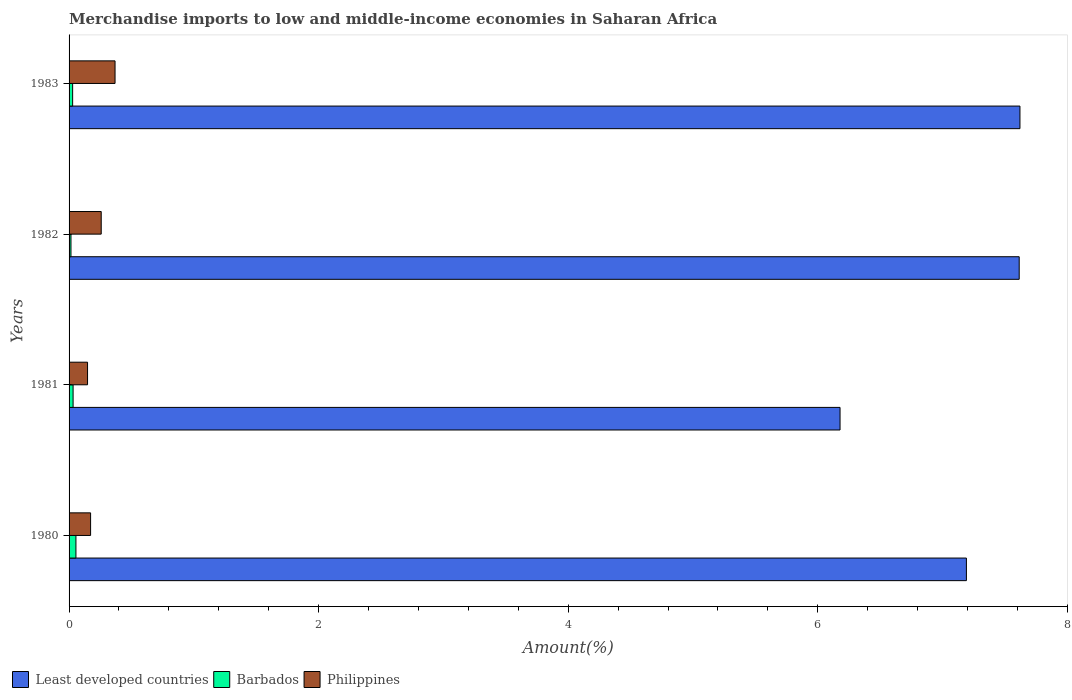How many different coloured bars are there?
Your answer should be very brief. 3. How many groups of bars are there?
Keep it short and to the point. 4. How many bars are there on the 1st tick from the bottom?
Your response must be concise. 3. What is the percentage of amount earned from merchandise imports in Philippines in 1980?
Ensure brevity in your answer.  0.17. Across all years, what is the maximum percentage of amount earned from merchandise imports in Barbados?
Offer a very short reply. 0.05. Across all years, what is the minimum percentage of amount earned from merchandise imports in Least developed countries?
Offer a terse response. 6.18. In which year was the percentage of amount earned from merchandise imports in Philippines minimum?
Offer a very short reply. 1981. What is the total percentage of amount earned from merchandise imports in Barbados in the graph?
Offer a terse response. 0.13. What is the difference between the percentage of amount earned from merchandise imports in Least developed countries in 1980 and that in 1983?
Provide a short and direct response. -0.43. What is the difference between the percentage of amount earned from merchandise imports in Barbados in 1981 and the percentage of amount earned from merchandise imports in Least developed countries in 1983?
Keep it short and to the point. -7.59. What is the average percentage of amount earned from merchandise imports in Philippines per year?
Provide a succinct answer. 0.24. In the year 1981, what is the difference between the percentage of amount earned from merchandise imports in Philippines and percentage of amount earned from merchandise imports in Least developed countries?
Your answer should be compact. -6.03. What is the ratio of the percentage of amount earned from merchandise imports in Least developed countries in 1981 to that in 1983?
Your response must be concise. 0.81. Is the percentage of amount earned from merchandise imports in Philippines in 1980 less than that in 1981?
Make the answer very short. No. What is the difference between the highest and the second highest percentage of amount earned from merchandise imports in Barbados?
Your response must be concise. 0.02. What is the difference between the highest and the lowest percentage of amount earned from merchandise imports in Least developed countries?
Your response must be concise. 1.44. What does the 2nd bar from the top in 1980 represents?
Provide a succinct answer. Barbados. What does the 2nd bar from the bottom in 1982 represents?
Make the answer very short. Barbados. Is it the case that in every year, the sum of the percentage of amount earned from merchandise imports in Philippines and percentage of amount earned from merchandise imports in Barbados is greater than the percentage of amount earned from merchandise imports in Least developed countries?
Offer a very short reply. No. How many bars are there?
Give a very brief answer. 12. Are all the bars in the graph horizontal?
Your answer should be very brief. Yes. How many years are there in the graph?
Your answer should be very brief. 4. Are the values on the major ticks of X-axis written in scientific E-notation?
Make the answer very short. No. Does the graph contain any zero values?
Your answer should be compact. No. Does the graph contain grids?
Keep it short and to the point. No. Where does the legend appear in the graph?
Your answer should be very brief. Bottom left. How many legend labels are there?
Your response must be concise. 3. How are the legend labels stacked?
Keep it short and to the point. Horizontal. What is the title of the graph?
Offer a very short reply. Merchandise imports to low and middle-income economies in Saharan Africa. What is the label or title of the X-axis?
Ensure brevity in your answer.  Amount(%). What is the Amount(%) in Least developed countries in 1980?
Offer a very short reply. 7.19. What is the Amount(%) in Barbados in 1980?
Ensure brevity in your answer.  0.05. What is the Amount(%) of Philippines in 1980?
Your answer should be very brief. 0.17. What is the Amount(%) of Least developed countries in 1981?
Provide a short and direct response. 6.18. What is the Amount(%) of Barbados in 1981?
Your answer should be very brief. 0.03. What is the Amount(%) of Philippines in 1981?
Your answer should be compact. 0.15. What is the Amount(%) in Least developed countries in 1982?
Provide a short and direct response. 7.61. What is the Amount(%) in Barbados in 1982?
Your response must be concise. 0.02. What is the Amount(%) of Philippines in 1982?
Your answer should be very brief. 0.26. What is the Amount(%) in Least developed countries in 1983?
Provide a short and direct response. 7.62. What is the Amount(%) of Barbados in 1983?
Your answer should be compact. 0.03. What is the Amount(%) in Philippines in 1983?
Offer a very short reply. 0.37. Across all years, what is the maximum Amount(%) of Least developed countries?
Give a very brief answer. 7.62. Across all years, what is the maximum Amount(%) in Barbados?
Provide a succinct answer. 0.05. Across all years, what is the maximum Amount(%) in Philippines?
Offer a terse response. 0.37. Across all years, what is the minimum Amount(%) of Least developed countries?
Offer a very short reply. 6.18. Across all years, what is the minimum Amount(%) of Barbados?
Give a very brief answer. 0.02. Across all years, what is the minimum Amount(%) of Philippines?
Offer a terse response. 0.15. What is the total Amount(%) of Least developed countries in the graph?
Make the answer very short. 28.6. What is the total Amount(%) of Barbados in the graph?
Ensure brevity in your answer.  0.13. What is the total Amount(%) in Philippines in the graph?
Ensure brevity in your answer.  0.95. What is the difference between the Amount(%) in Least developed countries in 1980 and that in 1981?
Ensure brevity in your answer.  1.01. What is the difference between the Amount(%) in Barbados in 1980 and that in 1981?
Provide a short and direct response. 0.02. What is the difference between the Amount(%) of Philippines in 1980 and that in 1981?
Provide a succinct answer. 0.02. What is the difference between the Amount(%) of Least developed countries in 1980 and that in 1982?
Keep it short and to the point. -0.42. What is the difference between the Amount(%) in Barbados in 1980 and that in 1982?
Your answer should be very brief. 0.04. What is the difference between the Amount(%) of Philippines in 1980 and that in 1982?
Ensure brevity in your answer.  -0.09. What is the difference between the Amount(%) in Least developed countries in 1980 and that in 1983?
Provide a succinct answer. -0.43. What is the difference between the Amount(%) in Barbados in 1980 and that in 1983?
Offer a very short reply. 0.03. What is the difference between the Amount(%) of Philippines in 1980 and that in 1983?
Provide a succinct answer. -0.2. What is the difference between the Amount(%) of Least developed countries in 1981 and that in 1982?
Make the answer very short. -1.44. What is the difference between the Amount(%) in Barbados in 1981 and that in 1982?
Ensure brevity in your answer.  0.02. What is the difference between the Amount(%) of Philippines in 1981 and that in 1982?
Provide a succinct answer. -0.11. What is the difference between the Amount(%) of Least developed countries in 1981 and that in 1983?
Give a very brief answer. -1.44. What is the difference between the Amount(%) in Barbados in 1981 and that in 1983?
Offer a very short reply. 0. What is the difference between the Amount(%) of Philippines in 1981 and that in 1983?
Your answer should be compact. -0.22. What is the difference between the Amount(%) of Least developed countries in 1982 and that in 1983?
Offer a terse response. -0.01. What is the difference between the Amount(%) of Barbados in 1982 and that in 1983?
Offer a very short reply. -0.01. What is the difference between the Amount(%) in Philippines in 1982 and that in 1983?
Provide a short and direct response. -0.11. What is the difference between the Amount(%) in Least developed countries in 1980 and the Amount(%) in Barbados in 1981?
Your response must be concise. 7.16. What is the difference between the Amount(%) of Least developed countries in 1980 and the Amount(%) of Philippines in 1981?
Make the answer very short. 7.04. What is the difference between the Amount(%) of Barbados in 1980 and the Amount(%) of Philippines in 1981?
Offer a very short reply. -0.09. What is the difference between the Amount(%) in Least developed countries in 1980 and the Amount(%) in Barbados in 1982?
Your response must be concise. 7.18. What is the difference between the Amount(%) in Least developed countries in 1980 and the Amount(%) in Philippines in 1982?
Give a very brief answer. 6.93. What is the difference between the Amount(%) in Barbados in 1980 and the Amount(%) in Philippines in 1982?
Your answer should be compact. -0.2. What is the difference between the Amount(%) of Least developed countries in 1980 and the Amount(%) of Barbados in 1983?
Your answer should be very brief. 7.16. What is the difference between the Amount(%) of Least developed countries in 1980 and the Amount(%) of Philippines in 1983?
Your response must be concise. 6.82. What is the difference between the Amount(%) in Barbados in 1980 and the Amount(%) in Philippines in 1983?
Provide a short and direct response. -0.31. What is the difference between the Amount(%) of Least developed countries in 1981 and the Amount(%) of Barbados in 1982?
Ensure brevity in your answer.  6.16. What is the difference between the Amount(%) in Least developed countries in 1981 and the Amount(%) in Philippines in 1982?
Your response must be concise. 5.92. What is the difference between the Amount(%) of Barbados in 1981 and the Amount(%) of Philippines in 1982?
Provide a short and direct response. -0.23. What is the difference between the Amount(%) of Least developed countries in 1981 and the Amount(%) of Barbados in 1983?
Offer a very short reply. 6.15. What is the difference between the Amount(%) in Least developed countries in 1981 and the Amount(%) in Philippines in 1983?
Provide a short and direct response. 5.81. What is the difference between the Amount(%) of Barbados in 1981 and the Amount(%) of Philippines in 1983?
Give a very brief answer. -0.34. What is the difference between the Amount(%) in Least developed countries in 1982 and the Amount(%) in Barbados in 1983?
Offer a very short reply. 7.59. What is the difference between the Amount(%) in Least developed countries in 1982 and the Amount(%) in Philippines in 1983?
Offer a very short reply. 7.25. What is the difference between the Amount(%) in Barbados in 1982 and the Amount(%) in Philippines in 1983?
Offer a terse response. -0.35. What is the average Amount(%) of Least developed countries per year?
Give a very brief answer. 7.15. What is the average Amount(%) of Barbados per year?
Provide a succinct answer. 0.03. What is the average Amount(%) of Philippines per year?
Give a very brief answer. 0.24. In the year 1980, what is the difference between the Amount(%) of Least developed countries and Amount(%) of Barbados?
Ensure brevity in your answer.  7.14. In the year 1980, what is the difference between the Amount(%) in Least developed countries and Amount(%) in Philippines?
Ensure brevity in your answer.  7.02. In the year 1980, what is the difference between the Amount(%) in Barbados and Amount(%) in Philippines?
Keep it short and to the point. -0.12. In the year 1981, what is the difference between the Amount(%) of Least developed countries and Amount(%) of Barbados?
Ensure brevity in your answer.  6.15. In the year 1981, what is the difference between the Amount(%) of Least developed countries and Amount(%) of Philippines?
Give a very brief answer. 6.03. In the year 1981, what is the difference between the Amount(%) of Barbados and Amount(%) of Philippines?
Your answer should be compact. -0.12. In the year 1982, what is the difference between the Amount(%) in Least developed countries and Amount(%) in Barbados?
Offer a very short reply. 7.6. In the year 1982, what is the difference between the Amount(%) of Least developed countries and Amount(%) of Philippines?
Give a very brief answer. 7.36. In the year 1982, what is the difference between the Amount(%) of Barbados and Amount(%) of Philippines?
Make the answer very short. -0.24. In the year 1983, what is the difference between the Amount(%) in Least developed countries and Amount(%) in Barbados?
Offer a terse response. 7.59. In the year 1983, what is the difference between the Amount(%) in Least developed countries and Amount(%) in Philippines?
Keep it short and to the point. 7.25. In the year 1983, what is the difference between the Amount(%) of Barbados and Amount(%) of Philippines?
Your answer should be very brief. -0.34. What is the ratio of the Amount(%) of Least developed countries in 1980 to that in 1981?
Your answer should be very brief. 1.16. What is the ratio of the Amount(%) of Barbados in 1980 to that in 1981?
Your answer should be compact. 1.71. What is the ratio of the Amount(%) of Philippines in 1980 to that in 1981?
Offer a terse response. 1.17. What is the ratio of the Amount(%) in Barbados in 1980 to that in 1982?
Your answer should be compact. 3.62. What is the ratio of the Amount(%) in Philippines in 1980 to that in 1982?
Offer a terse response. 0.67. What is the ratio of the Amount(%) in Least developed countries in 1980 to that in 1983?
Keep it short and to the point. 0.94. What is the ratio of the Amount(%) in Barbados in 1980 to that in 1983?
Keep it short and to the point. 1.92. What is the ratio of the Amount(%) in Philippines in 1980 to that in 1983?
Offer a terse response. 0.47. What is the ratio of the Amount(%) of Least developed countries in 1981 to that in 1982?
Ensure brevity in your answer.  0.81. What is the ratio of the Amount(%) in Barbados in 1981 to that in 1982?
Make the answer very short. 2.12. What is the ratio of the Amount(%) in Philippines in 1981 to that in 1982?
Your response must be concise. 0.57. What is the ratio of the Amount(%) of Least developed countries in 1981 to that in 1983?
Offer a terse response. 0.81. What is the ratio of the Amount(%) of Barbados in 1981 to that in 1983?
Offer a very short reply. 1.13. What is the ratio of the Amount(%) in Philippines in 1981 to that in 1983?
Ensure brevity in your answer.  0.4. What is the ratio of the Amount(%) in Least developed countries in 1982 to that in 1983?
Give a very brief answer. 1. What is the ratio of the Amount(%) of Barbados in 1982 to that in 1983?
Ensure brevity in your answer.  0.53. What is the ratio of the Amount(%) of Philippines in 1982 to that in 1983?
Your response must be concise. 0.7. What is the difference between the highest and the second highest Amount(%) in Least developed countries?
Your response must be concise. 0.01. What is the difference between the highest and the second highest Amount(%) in Barbados?
Provide a succinct answer. 0.02. What is the difference between the highest and the second highest Amount(%) in Philippines?
Keep it short and to the point. 0.11. What is the difference between the highest and the lowest Amount(%) in Least developed countries?
Ensure brevity in your answer.  1.44. What is the difference between the highest and the lowest Amount(%) of Barbados?
Your response must be concise. 0.04. What is the difference between the highest and the lowest Amount(%) of Philippines?
Your answer should be very brief. 0.22. 